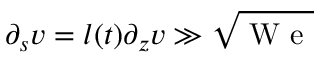Convert formula to latex. <formula><loc_0><loc_0><loc_500><loc_500>\partial _ { s } v = l ( t ) \partial _ { z } v \gg \sqrt { W e }</formula> 